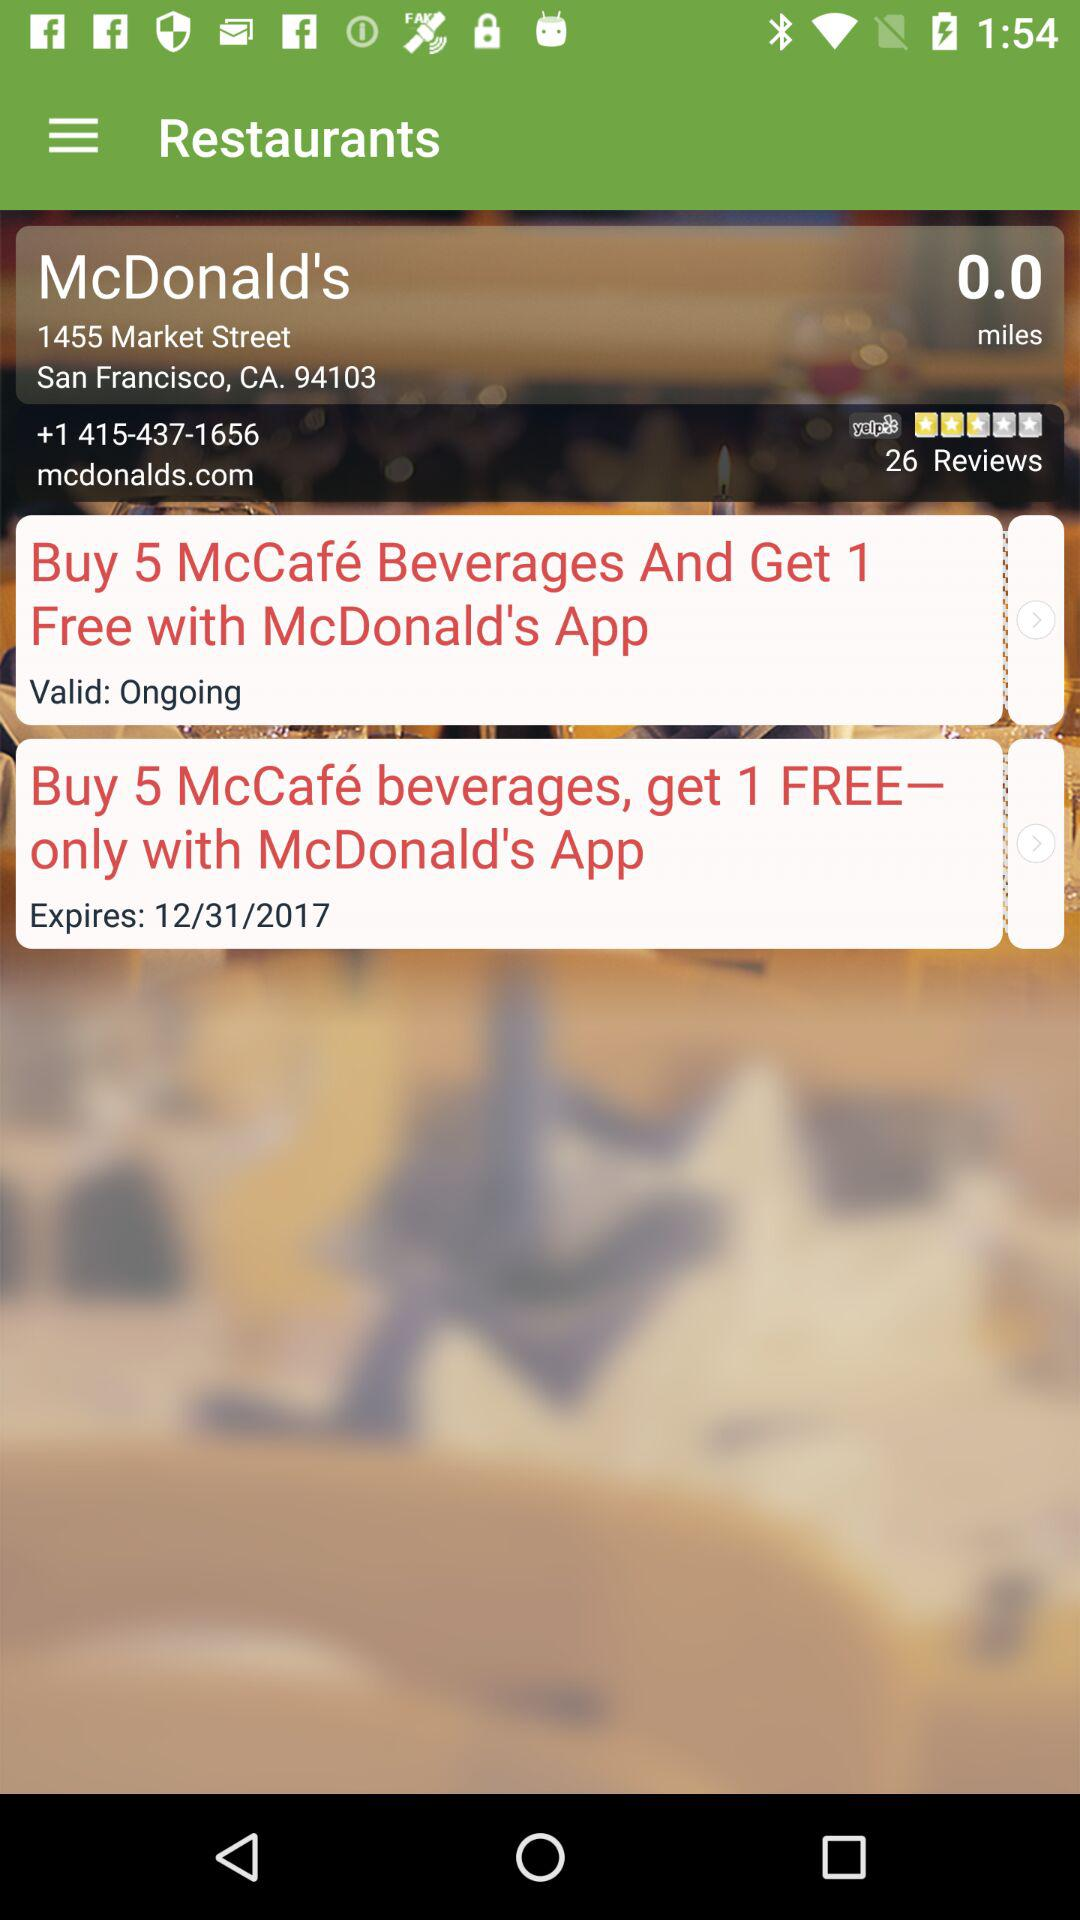What is the offer of McDonald's? The offers are "Buy 5 McCafé Beverages And Get 1 Free with McDonald's App" and "Buy 5 McCafé beverages, get 1 FREE— only with McDonald's App". 